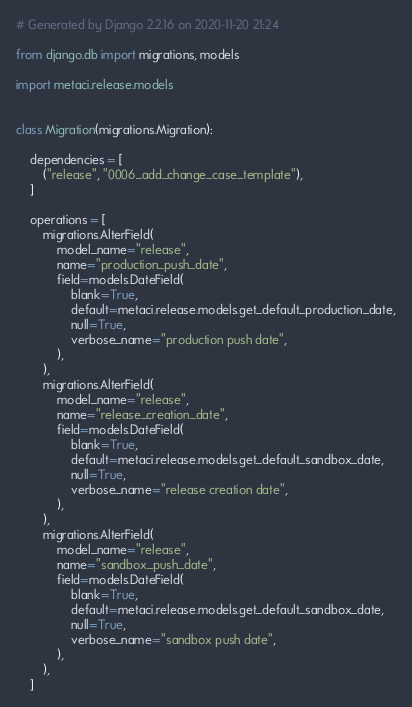Convert code to text. <code><loc_0><loc_0><loc_500><loc_500><_Python_># Generated by Django 2.2.16 on 2020-11-20 21:24

from django.db import migrations, models

import metaci.release.models


class Migration(migrations.Migration):

    dependencies = [
        ("release", "0006_add_change_case_template"),
    ]

    operations = [
        migrations.AlterField(
            model_name="release",
            name="production_push_date",
            field=models.DateField(
                blank=True,
                default=metaci.release.models.get_default_production_date,
                null=True,
                verbose_name="production push date",
            ),
        ),
        migrations.AlterField(
            model_name="release",
            name="release_creation_date",
            field=models.DateField(
                blank=True,
                default=metaci.release.models.get_default_sandbox_date,
                null=True,
                verbose_name="release creation date",
            ),
        ),
        migrations.AlterField(
            model_name="release",
            name="sandbox_push_date",
            field=models.DateField(
                blank=True,
                default=metaci.release.models.get_default_sandbox_date,
                null=True,
                verbose_name="sandbox push date",
            ),
        ),
    ]
</code> 